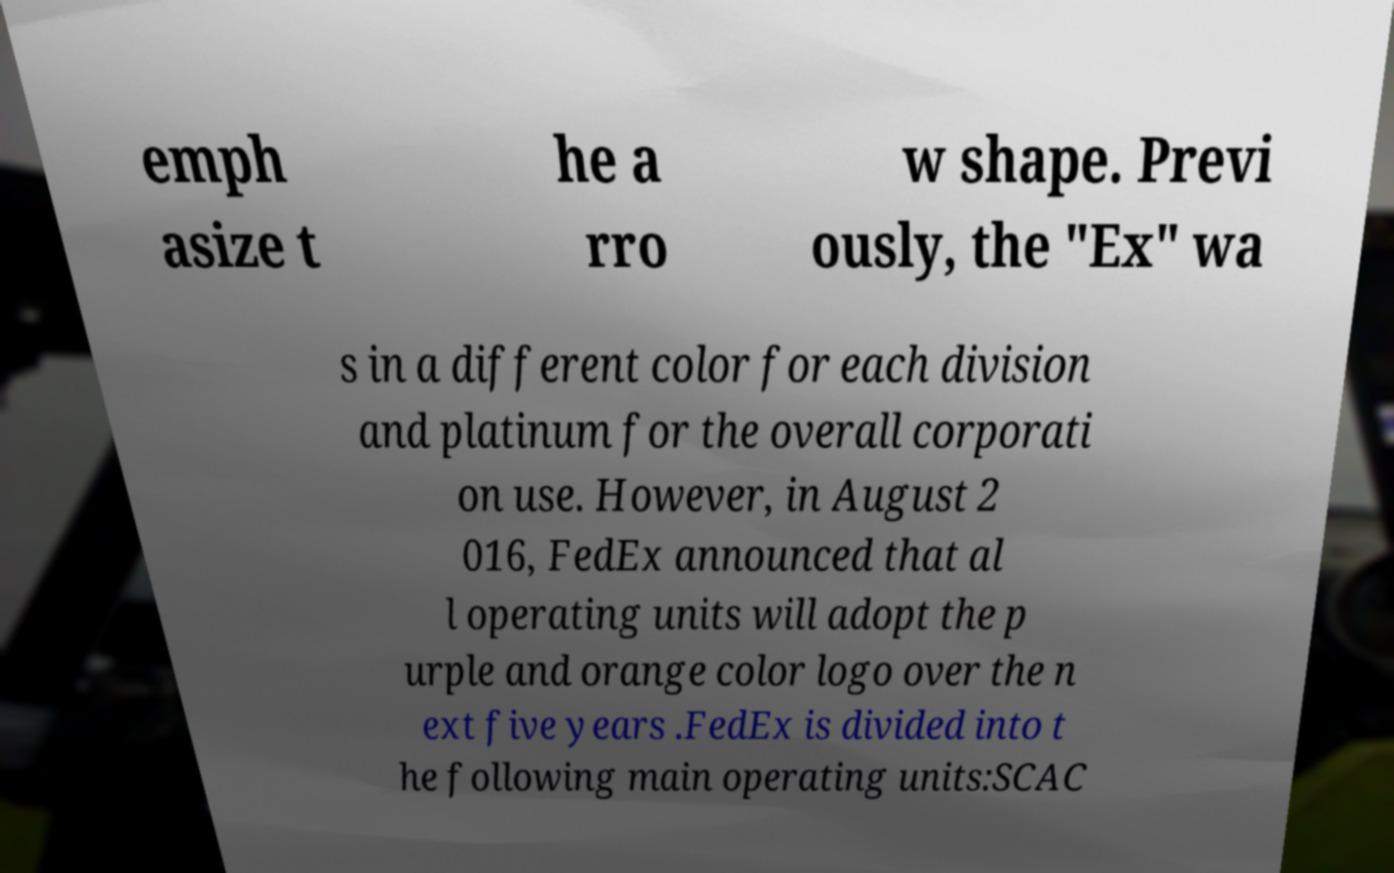Please identify and transcribe the text found in this image. emph asize t he a rro w shape. Previ ously, the "Ex" wa s in a different color for each division and platinum for the overall corporati on use. However, in August 2 016, FedEx announced that al l operating units will adopt the p urple and orange color logo over the n ext five years .FedEx is divided into t he following main operating units:SCAC 